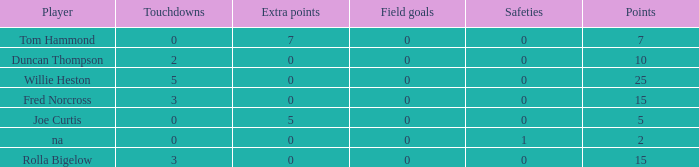How many Touchdowns have a Player of rolla bigelow, and an Extra points smaller than 0? None. 